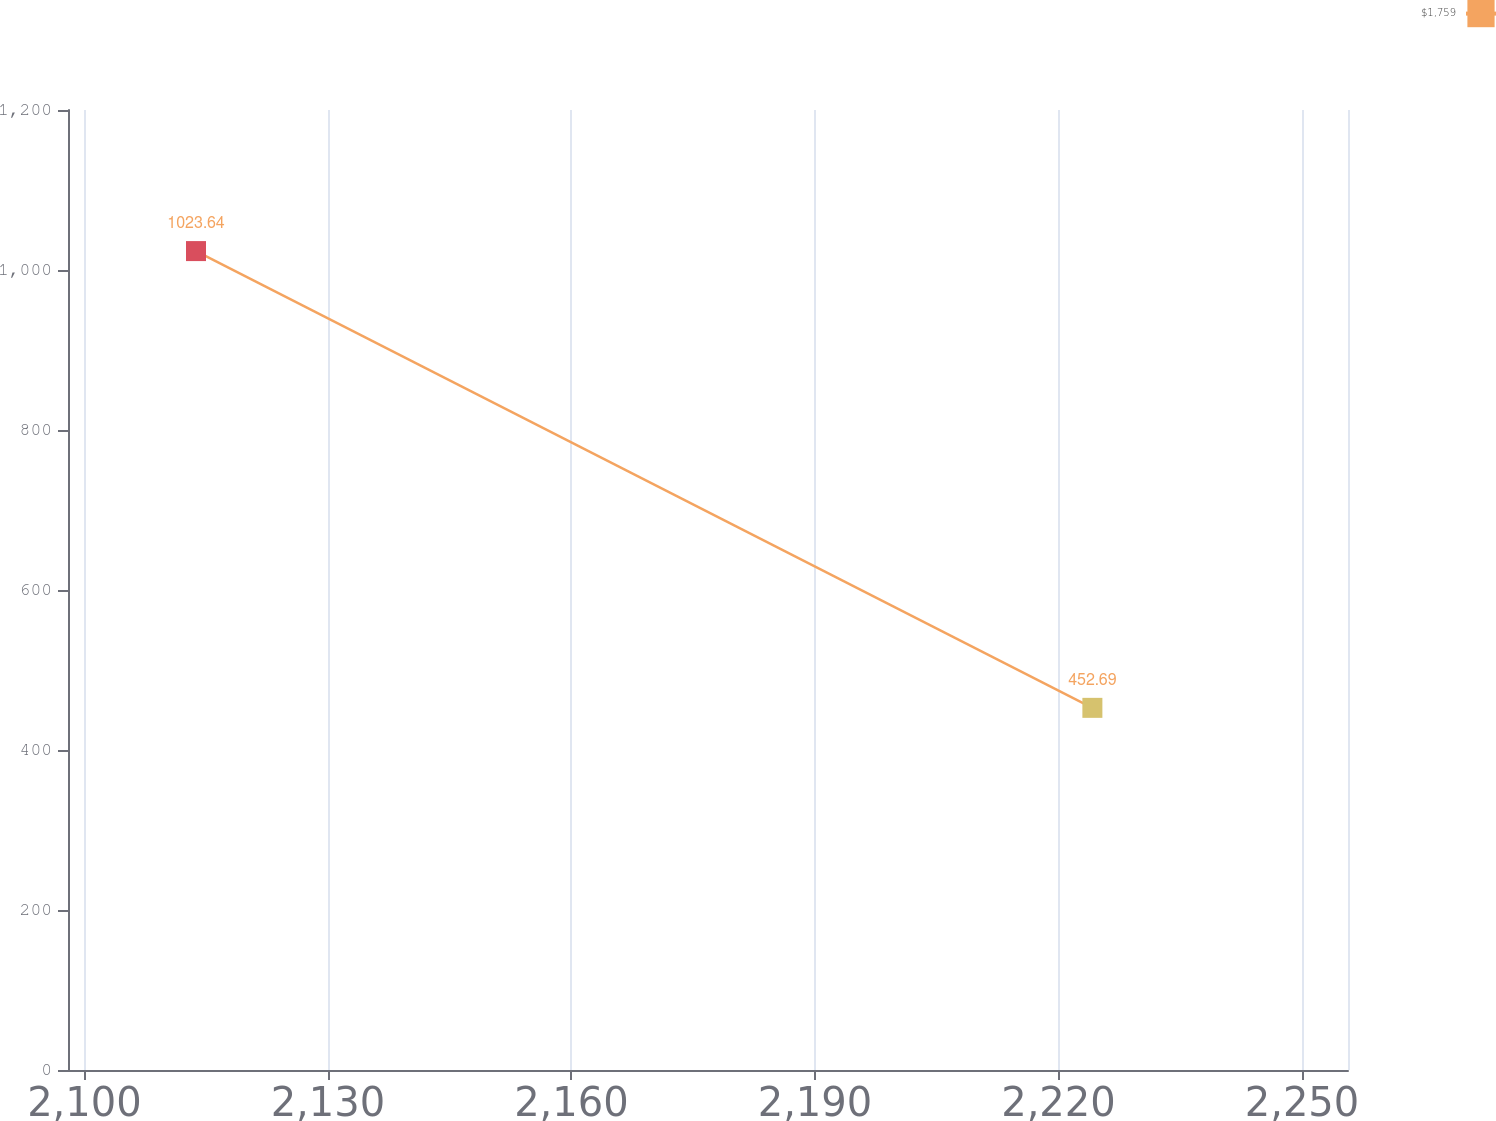Convert chart. <chart><loc_0><loc_0><loc_500><loc_500><line_chart><ecel><fcel>$1,759<nl><fcel>2113.75<fcel>1023.64<nl><fcel>2224.18<fcel>452.69<nl><fcel>2271.44<fcel>13.31<nl></chart> 